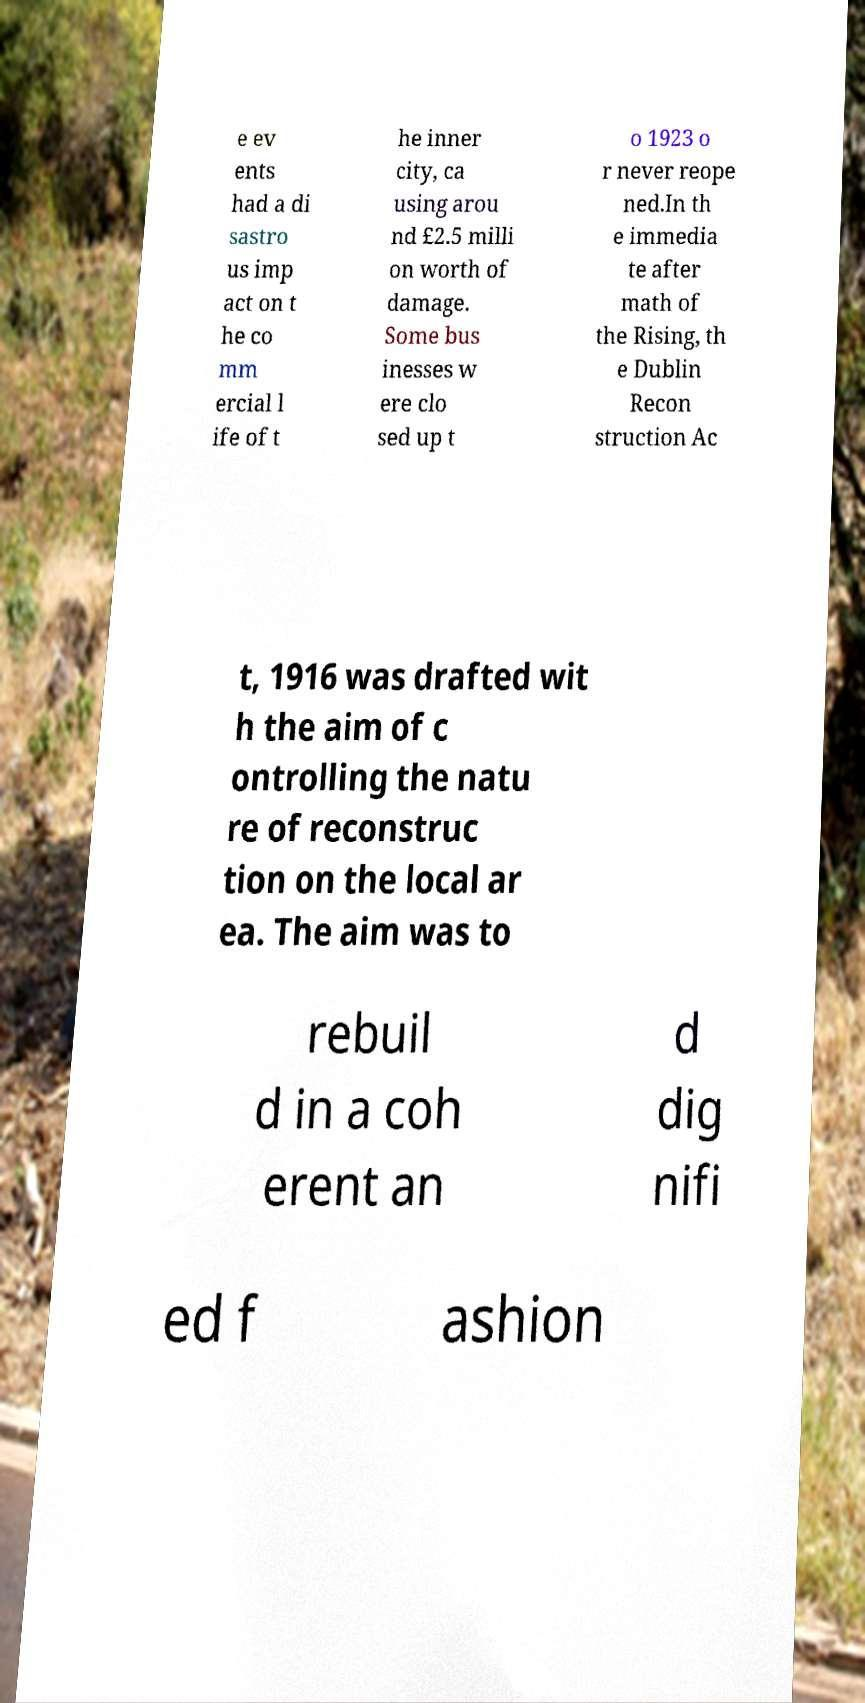Could you assist in decoding the text presented in this image and type it out clearly? e ev ents had a di sastro us imp act on t he co mm ercial l ife of t he inner city, ca using arou nd £2.5 milli on worth of damage. Some bus inesses w ere clo sed up t o 1923 o r never reope ned.In th e immedia te after math of the Rising, th e Dublin Recon struction Ac t, 1916 was drafted wit h the aim of c ontrolling the natu re of reconstruc tion on the local ar ea. The aim was to rebuil d in a coh erent an d dig nifi ed f ashion 